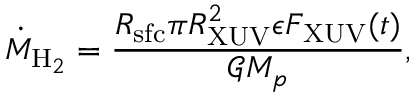Convert formula to latex. <formula><loc_0><loc_0><loc_500><loc_500>\dot { M } _ { H _ { 2 } } = \frac { R _ { s f c } \pi R _ { X U V } ^ { 2 } \epsilon F _ { X U V } ( t ) } { \mathcal { G } M _ { p } } ,</formula> 